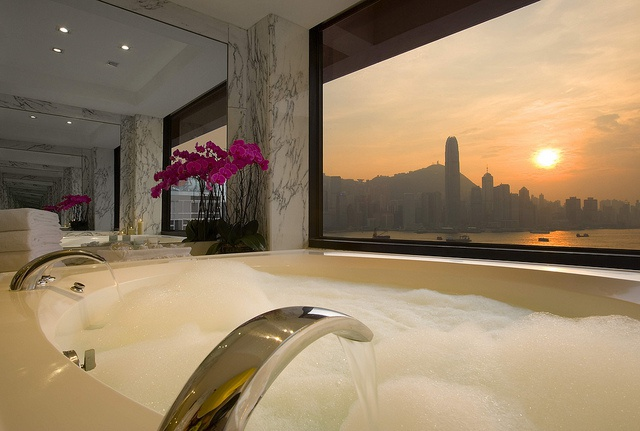Describe the objects in this image and their specific colors. I can see potted plant in gray, purple, and black tones, potted plant in gray, black, and purple tones, boat in gray and black tones, boat in gray, maroon, black, and olive tones, and boat in gray and black tones in this image. 